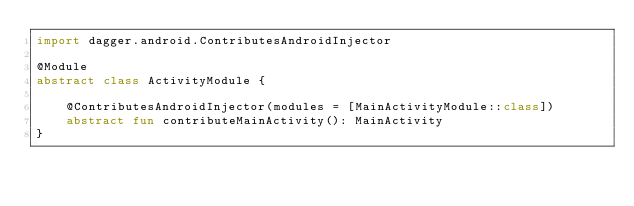<code> <loc_0><loc_0><loc_500><loc_500><_Kotlin_>import dagger.android.ContributesAndroidInjector

@Module
abstract class ActivityModule {

    @ContributesAndroidInjector(modules = [MainActivityModule::class])
    abstract fun contributeMainActivity(): MainActivity
}
</code> 